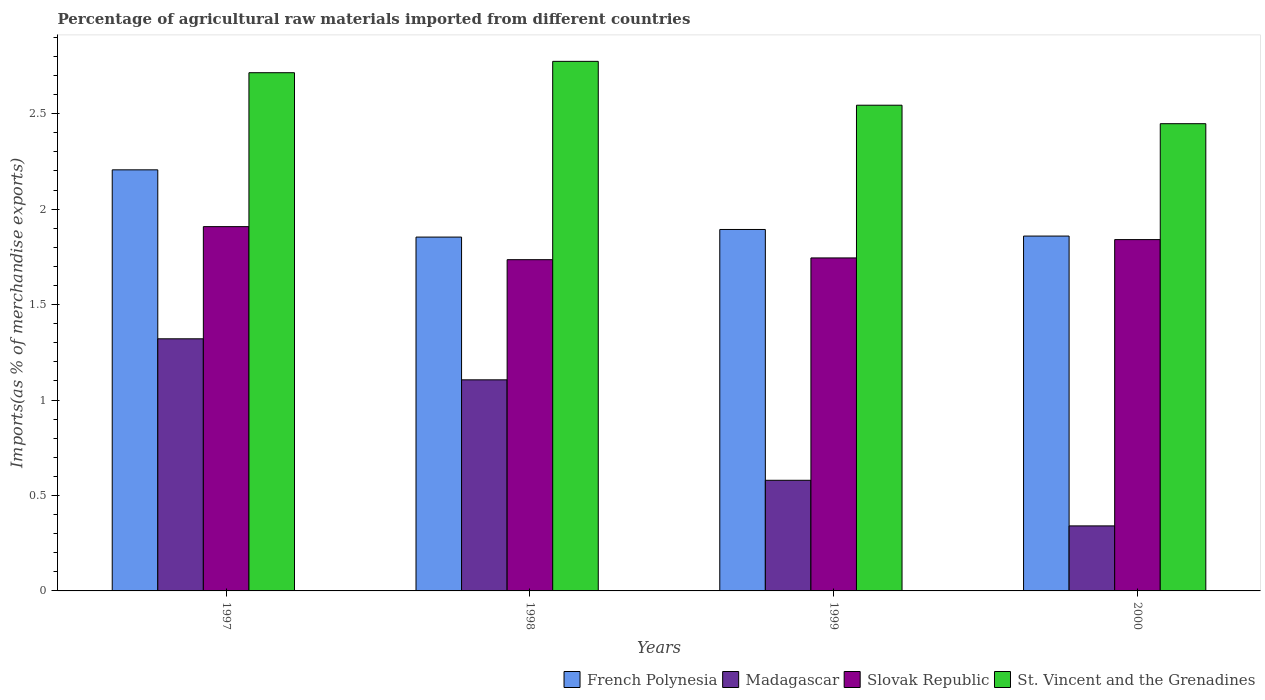Are the number of bars on each tick of the X-axis equal?
Your answer should be compact. Yes. How many bars are there on the 3rd tick from the right?
Make the answer very short. 4. What is the label of the 2nd group of bars from the left?
Provide a succinct answer. 1998. What is the percentage of imports to different countries in Madagascar in 1997?
Provide a succinct answer. 1.32. Across all years, what is the maximum percentage of imports to different countries in St. Vincent and the Grenadines?
Your answer should be compact. 2.77. Across all years, what is the minimum percentage of imports to different countries in French Polynesia?
Provide a succinct answer. 1.85. In which year was the percentage of imports to different countries in St. Vincent and the Grenadines maximum?
Your response must be concise. 1998. What is the total percentage of imports to different countries in St. Vincent and the Grenadines in the graph?
Ensure brevity in your answer.  10.48. What is the difference between the percentage of imports to different countries in Slovak Republic in 1998 and that in 2000?
Provide a short and direct response. -0.11. What is the difference between the percentage of imports to different countries in French Polynesia in 2000 and the percentage of imports to different countries in Madagascar in 1999?
Your answer should be compact. 1.28. What is the average percentage of imports to different countries in Madagascar per year?
Offer a very short reply. 0.84. In the year 1999, what is the difference between the percentage of imports to different countries in French Polynesia and percentage of imports to different countries in Slovak Republic?
Your response must be concise. 0.15. What is the ratio of the percentage of imports to different countries in Slovak Republic in 1998 to that in 2000?
Keep it short and to the point. 0.94. What is the difference between the highest and the second highest percentage of imports to different countries in St. Vincent and the Grenadines?
Your answer should be very brief. 0.06. What is the difference between the highest and the lowest percentage of imports to different countries in Slovak Republic?
Provide a short and direct response. 0.17. In how many years, is the percentage of imports to different countries in St. Vincent and the Grenadines greater than the average percentage of imports to different countries in St. Vincent and the Grenadines taken over all years?
Your answer should be very brief. 2. Is the sum of the percentage of imports to different countries in Madagascar in 1999 and 2000 greater than the maximum percentage of imports to different countries in French Polynesia across all years?
Ensure brevity in your answer.  No. Is it the case that in every year, the sum of the percentage of imports to different countries in Slovak Republic and percentage of imports to different countries in French Polynesia is greater than the sum of percentage of imports to different countries in St. Vincent and the Grenadines and percentage of imports to different countries in Madagascar?
Ensure brevity in your answer.  Yes. What does the 1st bar from the left in 2000 represents?
Offer a terse response. French Polynesia. What does the 1st bar from the right in 1997 represents?
Offer a terse response. St. Vincent and the Grenadines. How many bars are there?
Offer a terse response. 16. Are all the bars in the graph horizontal?
Make the answer very short. No. How many years are there in the graph?
Provide a succinct answer. 4. What is the difference between two consecutive major ticks on the Y-axis?
Make the answer very short. 0.5. Does the graph contain any zero values?
Your answer should be compact. No. Does the graph contain grids?
Keep it short and to the point. No. Where does the legend appear in the graph?
Your answer should be very brief. Bottom right. What is the title of the graph?
Offer a terse response. Percentage of agricultural raw materials imported from different countries. What is the label or title of the Y-axis?
Offer a very short reply. Imports(as % of merchandise exports). What is the Imports(as % of merchandise exports) in French Polynesia in 1997?
Keep it short and to the point. 2.21. What is the Imports(as % of merchandise exports) of Madagascar in 1997?
Ensure brevity in your answer.  1.32. What is the Imports(as % of merchandise exports) in Slovak Republic in 1997?
Make the answer very short. 1.91. What is the Imports(as % of merchandise exports) in St. Vincent and the Grenadines in 1997?
Offer a very short reply. 2.71. What is the Imports(as % of merchandise exports) of French Polynesia in 1998?
Provide a short and direct response. 1.85. What is the Imports(as % of merchandise exports) in Madagascar in 1998?
Make the answer very short. 1.11. What is the Imports(as % of merchandise exports) in Slovak Republic in 1998?
Offer a very short reply. 1.74. What is the Imports(as % of merchandise exports) of St. Vincent and the Grenadines in 1998?
Provide a succinct answer. 2.77. What is the Imports(as % of merchandise exports) of French Polynesia in 1999?
Your response must be concise. 1.89. What is the Imports(as % of merchandise exports) in Madagascar in 1999?
Give a very brief answer. 0.58. What is the Imports(as % of merchandise exports) in Slovak Republic in 1999?
Provide a succinct answer. 1.74. What is the Imports(as % of merchandise exports) in St. Vincent and the Grenadines in 1999?
Ensure brevity in your answer.  2.54. What is the Imports(as % of merchandise exports) of French Polynesia in 2000?
Your response must be concise. 1.86. What is the Imports(as % of merchandise exports) of Madagascar in 2000?
Provide a succinct answer. 0.34. What is the Imports(as % of merchandise exports) in Slovak Republic in 2000?
Your answer should be compact. 1.84. What is the Imports(as % of merchandise exports) of St. Vincent and the Grenadines in 2000?
Offer a terse response. 2.45. Across all years, what is the maximum Imports(as % of merchandise exports) of French Polynesia?
Keep it short and to the point. 2.21. Across all years, what is the maximum Imports(as % of merchandise exports) of Madagascar?
Keep it short and to the point. 1.32. Across all years, what is the maximum Imports(as % of merchandise exports) in Slovak Republic?
Your answer should be compact. 1.91. Across all years, what is the maximum Imports(as % of merchandise exports) of St. Vincent and the Grenadines?
Your answer should be compact. 2.77. Across all years, what is the minimum Imports(as % of merchandise exports) in French Polynesia?
Ensure brevity in your answer.  1.85. Across all years, what is the minimum Imports(as % of merchandise exports) of Madagascar?
Make the answer very short. 0.34. Across all years, what is the minimum Imports(as % of merchandise exports) of Slovak Republic?
Provide a short and direct response. 1.74. Across all years, what is the minimum Imports(as % of merchandise exports) in St. Vincent and the Grenadines?
Your answer should be very brief. 2.45. What is the total Imports(as % of merchandise exports) of French Polynesia in the graph?
Offer a terse response. 7.81. What is the total Imports(as % of merchandise exports) in Madagascar in the graph?
Ensure brevity in your answer.  3.35. What is the total Imports(as % of merchandise exports) in Slovak Republic in the graph?
Make the answer very short. 7.23. What is the total Imports(as % of merchandise exports) of St. Vincent and the Grenadines in the graph?
Provide a succinct answer. 10.48. What is the difference between the Imports(as % of merchandise exports) of French Polynesia in 1997 and that in 1998?
Your answer should be compact. 0.35. What is the difference between the Imports(as % of merchandise exports) in Madagascar in 1997 and that in 1998?
Your answer should be compact. 0.21. What is the difference between the Imports(as % of merchandise exports) of Slovak Republic in 1997 and that in 1998?
Your answer should be very brief. 0.17. What is the difference between the Imports(as % of merchandise exports) in St. Vincent and the Grenadines in 1997 and that in 1998?
Provide a short and direct response. -0.06. What is the difference between the Imports(as % of merchandise exports) of French Polynesia in 1997 and that in 1999?
Your answer should be very brief. 0.31. What is the difference between the Imports(as % of merchandise exports) of Madagascar in 1997 and that in 1999?
Your answer should be compact. 0.74. What is the difference between the Imports(as % of merchandise exports) of Slovak Republic in 1997 and that in 1999?
Your response must be concise. 0.16. What is the difference between the Imports(as % of merchandise exports) of St. Vincent and the Grenadines in 1997 and that in 1999?
Provide a short and direct response. 0.17. What is the difference between the Imports(as % of merchandise exports) in French Polynesia in 1997 and that in 2000?
Provide a succinct answer. 0.35. What is the difference between the Imports(as % of merchandise exports) of Madagascar in 1997 and that in 2000?
Make the answer very short. 0.98. What is the difference between the Imports(as % of merchandise exports) of Slovak Republic in 1997 and that in 2000?
Offer a very short reply. 0.07. What is the difference between the Imports(as % of merchandise exports) of St. Vincent and the Grenadines in 1997 and that in 2000?
Your answer should be very brief. 0.27. What is the difference between the Imports(as % of merchandise exports) of French Polynesia in 1998 and that in 1999?
Provide a short and direct response. -0.04. What is the difference between the Imports(as % of merchandise exports) in Madagascar in 1998 and that in 1999?
Make the answer very short. 0.53. What is the difference between the Imports(as % of merchandise exports) of Slovak Republic in 1998 and that in 1999?
Your answer should be very brief. -0.01. What is the difference between the Imports(as % of merchandise exports) in St. Vincent and the Grenadines in 1998 and that in 1999?
Your answer should be compact. 0.23. What is the difference between the Imports(as % of merchandise exports) in French Polynesia in 1998 and that in 2000?
Provide a succinct answer. -0.01. What is the difference between the Imports(as % of merchandise exports) of Madagascar in 1998 and that in 2000?
Give a very brief answer. 0.77. What is the difference between the Imports(as % of merchandise exports) in Slovak Republic in 1998 and that in 2000?
Give a very brief answer. -0.11. What is the difference between the Imports(as % of merchandise exports) in St. Vincent and the Grenadines in 1998 and that in 2000?
Offer a terse response. 0.33. What is the difference between the Imports(as % of merchandise exports) of French Polynesia in 1999 and that in 2000?
Provide a succinct answer. 0.03. What is the difference between the Imports(as % of merchandise exports) of Madagascar in 1999 and that in 2000?
Provide a short and direct response. 0.24. What is the difference between the Imports(as % of merchandise exports) in Slovak Republic in 1999 and that in 2000?
Provide a short and direct response. -0.1. What is the difference between the Imports(as % of merchandise exports) in St. Vincent and the Grenadines in 1999 and that in 2000?
Keep it short and to the point. 0.1. What is the difference between the Imports(as % of merchandise exports) in French Polynesia in 1997 and the Imports(as % of merchandise exports) in Madagascar in 1998?
Offer a terse response. 1.1. What is the difference between the Imports(as % of merchandise exports) in French Polynesia in 1997 and the Imports(as % of merchandise exports) in Slovak Republic in 1998?
Provide a short and direct response. 0.47. What is the difference between the Imports(as % of merchandise exports) of French Polynesia in 1997 and the Imports(as % of merchandise exports) of St. Vincent and the Grenadines in 1998?
Make the answer very short. -0.57. What is the difference between the Imports(as % of merchandise exports) in Madagascar in 1997 and the Imports(as % of merchandise exports) in Slovak Republic in 1998?
Your answer should be compact. -0.41. What is the difference between the Imports(as % of merchandise exports) in Madagascar in 1997 and the Imports(as % of merchandise exports) in St. Vincent and the Grenadines in 1998?
Offer a terse response. -1.45. What is the difference between the Imports(as % of merchandise exports) of Slovak Republic in 1997 and the Imports(as % of merchandise exports) of St. Vincent and the Grenadines in 1998?
Provide a short and direct response. -0.87. What is the difference between the Imports(as % of merchandise exports) in French Polynesia in 1997 and the Imports(as % of merchandise exports) in Madagascar in 1999?
Offer a terse response. 1.63. What is the difference between the Imports(as % of merchandise exports) of French Polynesia in 1997 and the Imports(as % of merchandise exports) of Slovak Republic in 1999?
Your response must be concise. 0.46. What is the difference between the Imports(as % of merchandise exports) of French Polynesia in 1997 and the Imports(as % of merchandise exports) of St. Vincent and the Grenadines in 1999?
Offer a very short reply. -0.34. What is the difference between the Imports(as % of merchandise exports) in Madagascar in 1997 and the Imports(as % of merchandise exports) in Slovak Republic in 1999?
Your response must be concise. -0.42. What is the difference between the Imports(as % of merchandise exports) in Madagascar in 1997 and the Imports(as % of merchandise exports) in St. Vincent and the Grenadines in 1999?
Keep it short and to the point. -1.22. What is the difference between the Imports(as % of merchandise exports) in Slovak Republic in 1997 and the Imports(as % of merchandise exports) in St. Vincent and the Grenadines in 1999?
Your answer should be compact. -0.64. What is the difference between the Imports(as % of merchandise exports) of French Polynesia in 1997 and the Imports(as % of merchandise exports) of Madagascar in 2000?
Give a very brief answer. 1.87. What is the difference between the Imports(as % of merchandise exports) of French Polynesia in 1997 and the Imports(as % of merchandise exports) of Slovak Republic in 2000?
Make the answer very short. 0.37. What is the difference between the Imports(as % of merchandise exports) of French Polynesia in 1997 and the Imports(as % of merchandise exports) of St. Vincent and the Grenadines in 2000?
Your response must be concise. -0.24. What is the difference between the Imports(as % of merchandise exports) of Madagascar in 1997 and the Imports(as % of merchandise exports) of Slovak Republic in 2000?
Make the answer very short. -0.52. What is the difference between the Imports(as % of merchandise exports) of Madagascar in 1997 and the Imports(as % of merchandise exports) of St. Vincent and the Grenadines in 2000?
Provide a succinct answer. -1.13. What is the difference between the Imports(as % of merchandise exports) of Slovak Republic in 1997 and the Imports(as % of merchandise exports) of St. Vincent and the Grenadines in 2000?
Your answer should be compact. -0.54. What is the difference between the Imports(as % of merchandise exports) of French Polynesia in 1998 and the Imports(as % of merchandise exports) of Madagascar in 1999?
Offer a very short reply. 1.27. What is the difference between the Imports(as % of merchandise exports) of French Polynesia in 1998 and the Imports(as % of merchandise exports) of Slovak Republic in 1999?
Make the answer very short. 0.11. What is the difference between the Imports(as % of merchandise exports) in French Polynesia in 1998 and the Imports(as % of merchandise exports) in St. Vincent and the Grenadines in 1999?
Give a very brief answer. -0.69. What is the difference between the Imports(as % of merchandise exports) in Madagascar in 1998 and the Imports(as % of merchandise exports) in Slovak Republic in 1999?
Offer a very short reply. -0.64. What is the difference between the Imports(as % of merchandise exports) of Madagascar in 1998 and the Imports(as % of merchandise exports) of St. Vincent and the Grenadines in 1999?
Ensure brevity in your answer.  -1.44. What is the difference between the Imports(as % of merchandise exports) of Slovak Republic in 1998 and the Imports(as % of merchandise exports) of St. Vincent and the Grenadines in 1999?
Ensure brevity in your answer.  -0.81. What is the difference between the Imports(as % of merchandise exports) of French Polynesia in 1998 and the Imports(as % of merchandise exports) of Madagascar in 2000?
Give a very brief answer. 1.51. What is the difference between the Imports(as % of merchandise exports) of French Polynesia in 1998 and the Imports(as % of merchandise exports) of Slovak Republic in 2000?
Offer a very short reply. 0.01. What is the difference between the Imports(as % of merchandise exports) in French Polynesia in 1998 and the Imports(as % of merchandise exports) in St. Vincent and the Grenadines in 2000?
Your answer should be very brief. -0.59. What is the difference between the Imports(as % of merchandise exports) of Madagascar in 1998 and the Imports(as % of merchandise exports) of Slovak Republic in 2000?
Make the answer very short. -0.73. What is the difference between the Imports(as % of merchandise exports) in Madagascar in 1998 and the Imports(as % of merchandise exports) in St. Vincent and the Grenadines in 2000?
Provide a short and direct response. -1.34. What is the difference between the Imports(as % of merchandise exports) of Slovak Republic in 1998 and the Imports(as % of merchandise exports) of St. Vincent and the Grenadines in 2000?
Provide a short and direct response. -0.71. What is the difference between the Imports(as % of merchandise exports) of French Polynesia in 1999 and the Imports(as % of merchandise exports) of Madagascar in 2000?
Provide a succinct answer. 1.55. What is the difference between the Imports(as % of merchandise exports) of French Polynesia in 1999 and the Imports(as % of merchandise exports) of Slovak Republic in 2000?
Your response must be concise. 0.05. What is the difference between the Imports(as % of merchandise exports) of French Polynesia in 1999 and the Imports(as % of merchandise exports) of St. Vincent and the Grenadines in 2000?
Your response must be concise. -0.55. What is the difference between the Imports(as % of merchandise exports) in Madagascar in 1999 and the Imports(as % of merchandise exports) in Slovak Republic in 2000?
Your response must be concise. -1.26. What is the difference between the Imports(as % of merchandise exports) in Madagascar in 1999 and the Imports(as % of merchandise exports) in St. Vincent and the Grenadines in 2000?
Provide a short and direct response. -1.87. What is the difference between the Imports(as % of merchandise exports) of Slovak Republic in 1999 and the Imports(as % of merchandise exports) of St. Vincent and the Grenadines in 2000?
Make the answer very short. -0.7. What is the average Imports(as % of merchandise exports) of French Polynesia per year?
Provide a short and direct response. 1.95. What is the average Imports(as % of merchandise exports) in Madagascar per year?
Offer a very short reply. 0.84. What is the average Imports(as % of merchandise exports) of Slovak Republic per year?
Provide a succinct answer. 1.81. What is the average Imports(as % of merchandise exports) of St. Vincent and the Grenadines per year?
Offer a very short reply. 2.62. In the year 1997, what is the difference between the Imports(as % of merchandise exports) in French Polynesia and Imports(as % of merchandise exports) in Madagascar?
Provide a succinct answer. 0.89. In the year 1997, what is the difference between the Imports(as % of merchandise exports) in French Polynesia and Imports(as % of merchandise exports) in Slovak Republic?
Provide a succinct answer. 0.3. In the year 1997, what is the difference between the Imports(as % of merchandise exports) of French Polynesia and Imports(as % of merchandise exports) of St. Vincent and the Grenadines?
Ensure brevity in your answer.  -0.51. In the year 1997, what is the difference between the Imports(as % of merchandise exports) in Madagascar and Imports(as % of merchandise exports) in Slovak Republic?
Your response must be concise. -0.59. In the year 1997, what is the difference between the Imports(as % of merchandise exports) of Madagascar and Imports(as % of merchandise exports) of St. Vincent and the Grenadines?
Provide a short and direct response. -1.39. In the year 1997, what is the difference between the Imports(as % of merchandise exports) in Slovak Republic and Imports(as % of merchandise exports) in St. Vincent and the Grenadines?
Ensure brevity in your answer.  -0.81. In the year 1998, what is the difference between the Imports(as % of merchandise exports) of French Polynesia and Imports(as % of merchandise exports) of Madagascar?
Offer a very short reply. 0.75. In the year 1998, what is the difference between the Imports(as % of merchandise exports) in French Polynesia and Imports(as % of merchandise exports) in Slovak Republic?
Ensure brevity in your answer.  0.12. In the year 1998, what is the difference between the Imports(as % of merchandise exports) of French Polynesia and Imports(as % of merchandise exports) of St. Vincent and the Grenadines?
Give a very brief answer. -0.92. In the year 1998, what is the difference between the Imports(as % of merchandise exports) in Madagascar and Imports(as % of merchandise exports) in Slovak Republic?
Your answer should be compact. -0.63. In the year 1998, what is the difference between the Imports(as % of merchandise exports) of Madagascar and Imports(as % of merchandise exports) of St. Vincent and the Grenadines?
Provide a short and direct response. -1.67. In the year 1998, what is the difference between the Imports(as % of merchandise exports) in Slovak Republic and Imports(as % of merchandise exports) in St. Vincent and the Grenadines?
Make the answer very short. -1.04. In the year 1999, what is the difference between the Imports(as % of merchandise exports) in French Polynesia and Imports(as % of merchandise exports) in Madagascar?
Your response must be concise. 1.31. In the year 1999, what is the difference between the Imports(as % of merchandise exports) in French Polynesia and Imports(as % of merchandise exports) in Slovak Republic?
Your answer should be compact. 0.15. In the year 1999, what is the difference between the Imports(as % of merchandise exports) of French Polynesia and Imports(as % of merchandise exports) of St. Vincent and the Grenadines?
Offer a terse response. -0.65. In the year 1999, what is the difference between the Imports(as % of merchandise exports) of Madagascar and Imports(as % of merchandise exports) of Slovak Republic?
Your response must be concise. -1.16. In the year 1999, what is the difference between the Imports(as % of merchandise exports) in Madagascar and Imports(as % of merchandise exports) in St. Vincent and the Grenadines?
Give a very brief answer. -1.97. In the year 1999, what is the difference between the Imports(as % of merchandise exports) of Slovak Republic and Imports(as % of merchandise exports) of St. Vincent and the Grenadines?
Your response must be concise. -0.8. In the year 2000, what is the difference between the Imports(as % of merchandise exports) in French Polynesia and Imports(as % of merchandise exports) in Madagascar?
Your answer should be compact. 1.52. In the year 2000, what is the difference between the Imports(as % of merchandise exports) in French Polynesia and Imports(as % of merchandise exports) in Slovak Republic?
Give a very brief answer. 0.02. In the year 2000, what is the difference between the Imports(as % of merchandise exports) in French Polynesia and Imports(as % of merchandise exports) in St. Vincent and the Grenadines?
Your answer should be very brief. -0.59. In the year 2000, what is the difference between the Imports(as % of merchandise exports) of Madagascar and Imports(as % of merchandise exports) of Slovak Republic?
Keep it short and to the point. -1.5. In the year 2000, what is the difference between the Imports(as % of merchandise exports) in Madagascar and Imports(as % of merchandise exports) in St. Vincent and the Grenadines?
Offer a terse response. -2.11. In the year 2000, what is the difference between the Imports(as % of merchandise exports) of Slovak Republic and Imports(as % of merchandise exports) of St. Vincent and the Grenadines?
Keep it short and to the point. -0.61. What is the ratio of the Imports(as % of merchandise exports) in French Polynesia in 1997 to that in 1998?
Provide a succinct answer. 1.19. What is the ratio of the Imports(as % of merchandise exports) in Madagascar in 1997 to that in 1998?
Provide a succinct answer. 1.19. What is the ratio of the Imports(as % of merchandise exports) of Slovak Republic in 1997 to that in 1998?
Your answer should be very brief. 1.1. What is the ratio of the Imports(as % of merchandise exports) in St. Vincent and the Grenadines in 1997 to that in 1998?
Keep it short and to the point. 0.98. What is the ratio of the Imports(as % of merchandise exports) in French Polynesia in 1997 to that in 1999?
Ensure brevity in your answer.  1.17. What is the ratio of the Imports(as % of merchandise exports) in Madagascar in 1997 to that in 1999?
Provide a succinct answer. 2.28. What is the ratio of the Imports(as % of merchandise exports) of Slovak Republic in 1997 to that in 1999?
Ensure brevity in your answer.  1.09. What is the ratio of the Imports(as % of merchandise exports) of St. Vincent and the Grenadines in 1997 to that in 1999?
Make the answer very short. 1.07. What is the ratio of the Imports(as % of merchandise exports) in French Polynesia in 1997 to that in 2000?
Your response must be concise. 1.19. What is the ratio of the Imports(as % of merchandise exports) of Madagascar in 1997 to that in 2000?
Provide a succinct answer. 3.88. What is the ratio of the Imports(as % of merchandise exports) in Slovak Republic in 1997 to that in 2000?
Your response must be concise. 1.04. What is the ratio of the Imports(as % of merchandise exports) of St. Vincent and the Grenadines in 1997 to that in 2000?
Make the answer very short. 1.11. What is the ratio of the Imports(as % of merchandise exports) of French Polynesia in 1998 to that in 1999?
Keep it short and to the point. 0.98. What is the ratio of the Imports(as % of merchandise exports) in Madagascar in 1998 to that in 1999?
Your answer should be very brief. 1.91. What is the ratio of the Imports(as % of merchandise exports) in Slovak Republic in 1998 to that in 1999?
Give a very brief answer. 0.99. What is the ratio of the Imports(as % of merchandise exports) in St. Vincent and the Grenadines in 1998 to that in 1999?
Keep it short and to the point. 1.09. What is the ratio of the Imports(as % of merchandise exports) of Madagascar in 1998 to that in 2000?
Your answer should be compact. 3.25. What is the ratio of the Imports(as % of merchandise exports) of Slovak Republic in 1998 to that in 2000?
Offer a terse response. 0.94. What is the ratio of the Imports(as % of merchandise exports) in St. Vincent and the Grenadines in 1998 to that in 2000?
Provide a succinct answer. 1.13. What is the ratio of the Imports(as % of merchandise exports) in French Polynesia in 1999 to that in 2000?
Your response must be concise. 1.02. What is the ratio of the Imports(as % of merchandise exports) in Madagascar in 1999 to that in 2000?
Offer a terse response. 1.7. What is the ratio of the Imports(as % of merchandise exports) of Slovak Republic in 1999 to that in 2000?
Provide a succinct answer. 0.95. What is the ratio of the Imports(as % of merchandise exports) of St. Vincent and the Grenadines in 1999 to that in 2000?
Ensure brevity in your answer.  1.04. What is the difference between the highest and the second highest Imports(as % of merchandise exports) in French Polynesia?
Your answer should be very brief. 0.31. What is the difference between the highest and the second highest Imports(as % of merchandise exports) of Madagascar?
Keep it short and to the point. 0.21. What is the difference between the highest and the second highest Imports(as % of merchandise exports) of Slovak Republic?
Ensure brevity in your answer.  0.07. What is the difference between the highest and the second highest Imports(as % of merchandise exports) in St. Vincent and the Grenadines?
Make the answer very short. 0.06. What is the difference between the highest and the lowest Imports(as % of merchandise exports) of French Polynesia?
Provide a succinct answer. 0.35. What is the difference between the highest and the lowest Imports(as % of merchandise exports) of Madagascar?
Your answer should be compact. 0.98. What is the difference between the highest and the lowest Imports(as % of merchandise exports) in Slovak Republic?
Your answer should be very brief. 0.17. What is the difference between the highest and the lowest Imports(as % of merchandise exports) of St. Vincent and the Grenadines?
Your response must be concise. 0.33. 